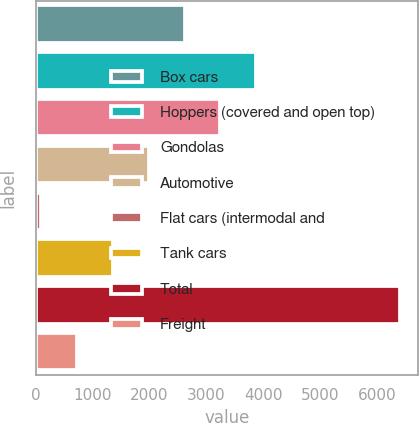Convert chart to OTSL. <chart><loc_0><loc_0><loc_500><loc_500><bar_chart><fcel>Box cars<fcel>Hoppers (covered and open top)<fcel>Gondolas<fcel>Automotive<fcel>Flat cars (intermodal and<fcel>Tank cars<fcel>Total<fcel>Freight<nl><fcel>2616.4<fcel>3875.6<fcel>3246<fcel>1986.8<fcel>98<fcel>1357.2<fcel>6394<fcel>727.6<nl></chart> 